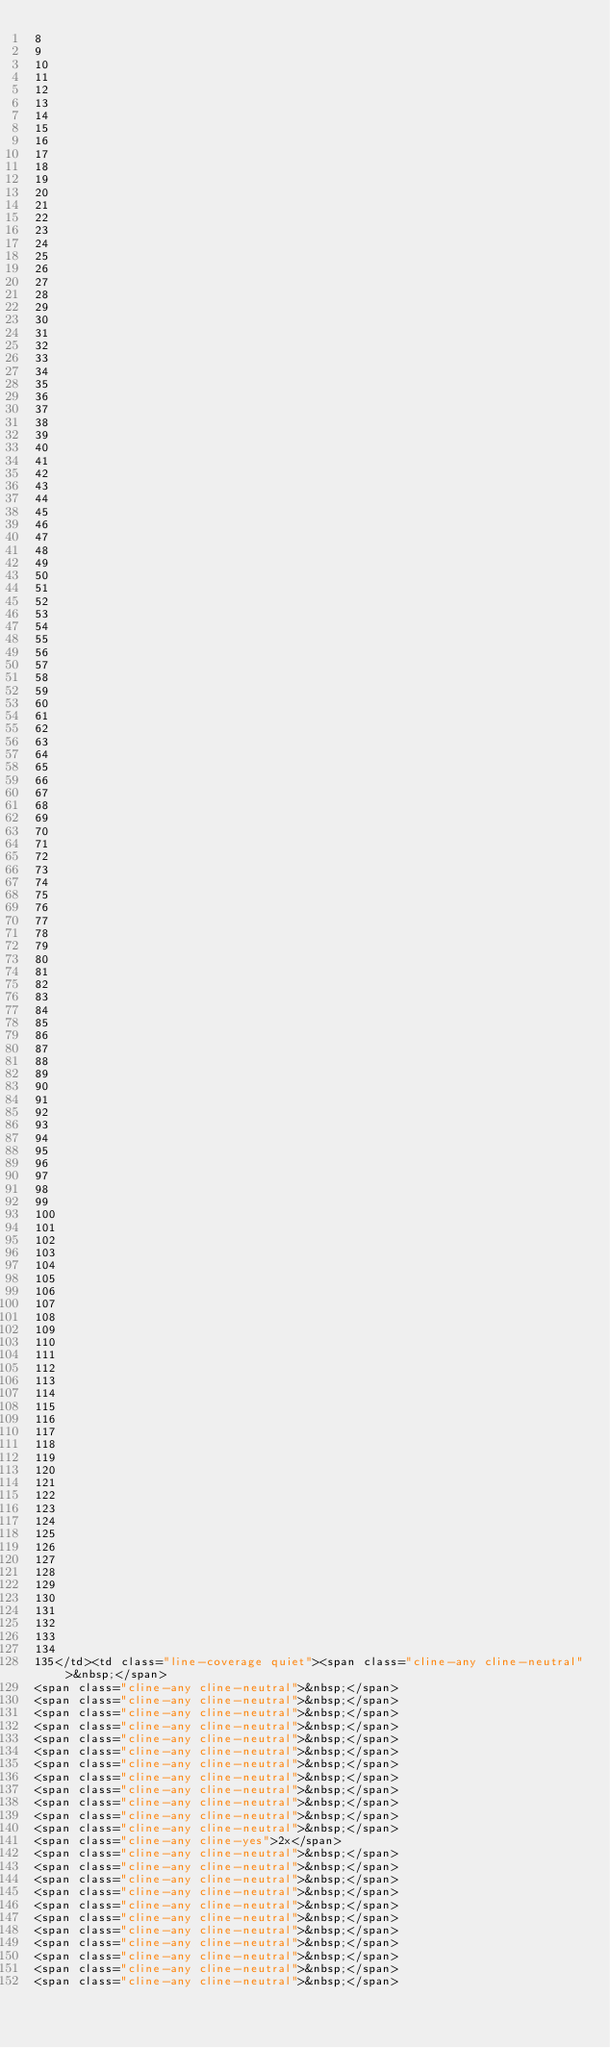Convert code to text. <code><loc_0><loc_0><loc_500><loc_500><_HTML_>8
9
10
11
12
13
14
15
16
17
18
19
20
21
22
23
24
25
26
27
28
29
30
31
32
33
34
35
36
37
38
39
40
41
42
43
44
45
46
47
48
49
50
51
52
53
54
55
56
57
58
59
60
61
62
63
64
65
66
67
68
69
70
71
72
73
74
75
76
77
78
79
80
81
82
83
84
85
86
87
88
89
90
91
92
93
94
95
96
97
98
99
100
101
102
103
104
105
106
107
108
109
110
111
112
113
114
115
116
117
118
119
120
121
122
123
124
125
126
127
128
129
130
131
132
133
134
135</td><td class="line-coverage quiet"><span class="cline-any cline-neutral">&nbsp;</span>
<span class="cline-any cline-neutral">&nbsp;</span>
<span class="cline-any cline-neutral">&nbsp;</span>
<span class="cline-any cline-neutral">&nbsp;</span>
<span class="cline-any cline-neutral">&nbsp;</span>
<span class="cline-any cline-neutral">&nbsp;</span>
<span class="cline-any cline-neutral">&nbsp;</span>
<span class="cline-any cline-neutral">&nbsp;</span>
<span class="cline-any cline-neutral">&nbsp;</span>
<span class="cline-any cline-neutral">&nbsp;</span>
<span class="cline-any cline-neutral">&nbsp;</span>
<span class="cline-any cline-neutral">&nbsp;</span>
<span class="cline-any cline-neutral">&nbsp;</span>
<span class="cline-any cline-yes">2x</span>
<span class="cline-any cline-neutral">&nbsp;</span>
<span class="cline-any cline-neutral">&nbsp;</span>
<span class="cline-any cline-neutral">&nbsp;</span>
<span class="cline-any cline-neutral">&nbsp;</span>
<span class="cline-any cline-neutral">&nbsp;</span>
<span class="cline-any cline-neutral">&nbsp;</span>
<span class="cline-any cline-neutral">&nbsp;</span>
<span class="cline-any cline-neutral">&nbsp;</span>
<span class="cline-any cline-neutral">&nbsp;</span>
<span class="cline-any cline-neutral">&nbsp;</span>
<span class="cline-any cline-neutral">&nbsp;</span></code> 